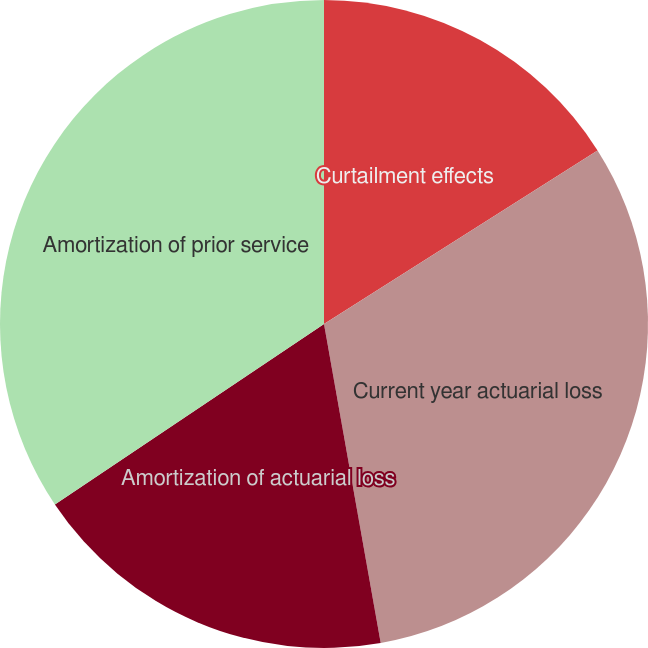Convert chart to OTSL. <chart><loc_0><loc_0><loc_500><loc_500><pie_chart><fcel>Curtailment effects<fcel>Current year actuarial loss<fcel>Amortization of actuarial loss<fcel>Amortization of prior service<nl><fcel>16.0%<fcel>31.2%<fcel>18.4%<fcel>34.4%<nl></chart> 